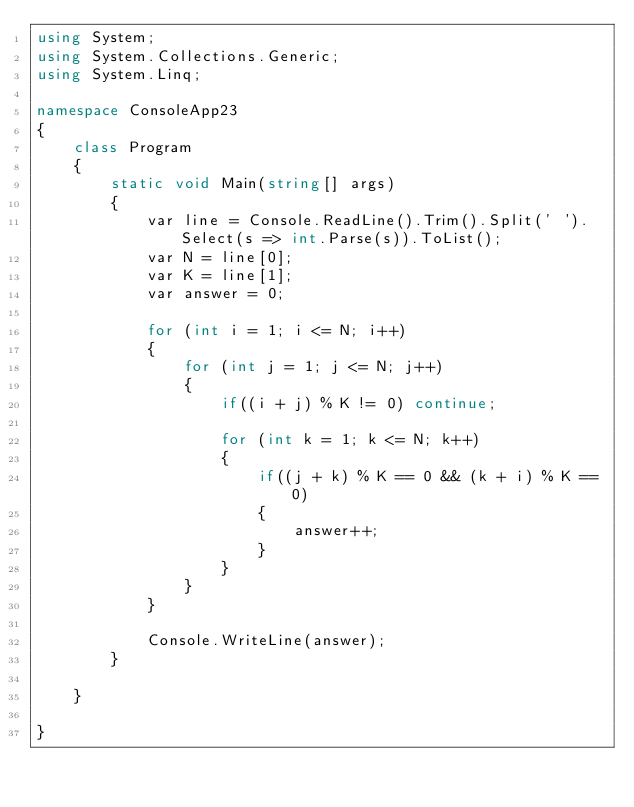Convert code to text. <code><loc_0><loc_0><loc_500><loc_500><_C#_>using System;
using System.Collections.Generic;
using System.Linq;

namespace ConsoleApp23
{
    class Program
    {
        static void Main(string[] args)
        {
            var line = Console.ReadLine().Trim().Split(' ').Select(s => int.Parse(s)).ToList();
            var N = line[0];
            var K = line[1];
            var answer = 0;

            for (int i = 1; i <= N; i++)
            {
                for (int j = 1; j <= N; j++)
                {
                    if((i + j) % K != 0) continue;

                    for (int k = 1; k <= N; k++)
                    {
                        if((j + k) % K == 0 && (k + i) % K == 0)
                        {
                            answer++;
                        }
                    }
                }
            }

            Console.WriteLine(answer);
        }

    }

}
</code> 